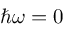<formula> <loc_0><loc_0><loc_500><loc_500>\hbar { \omega } = 0</formula> 